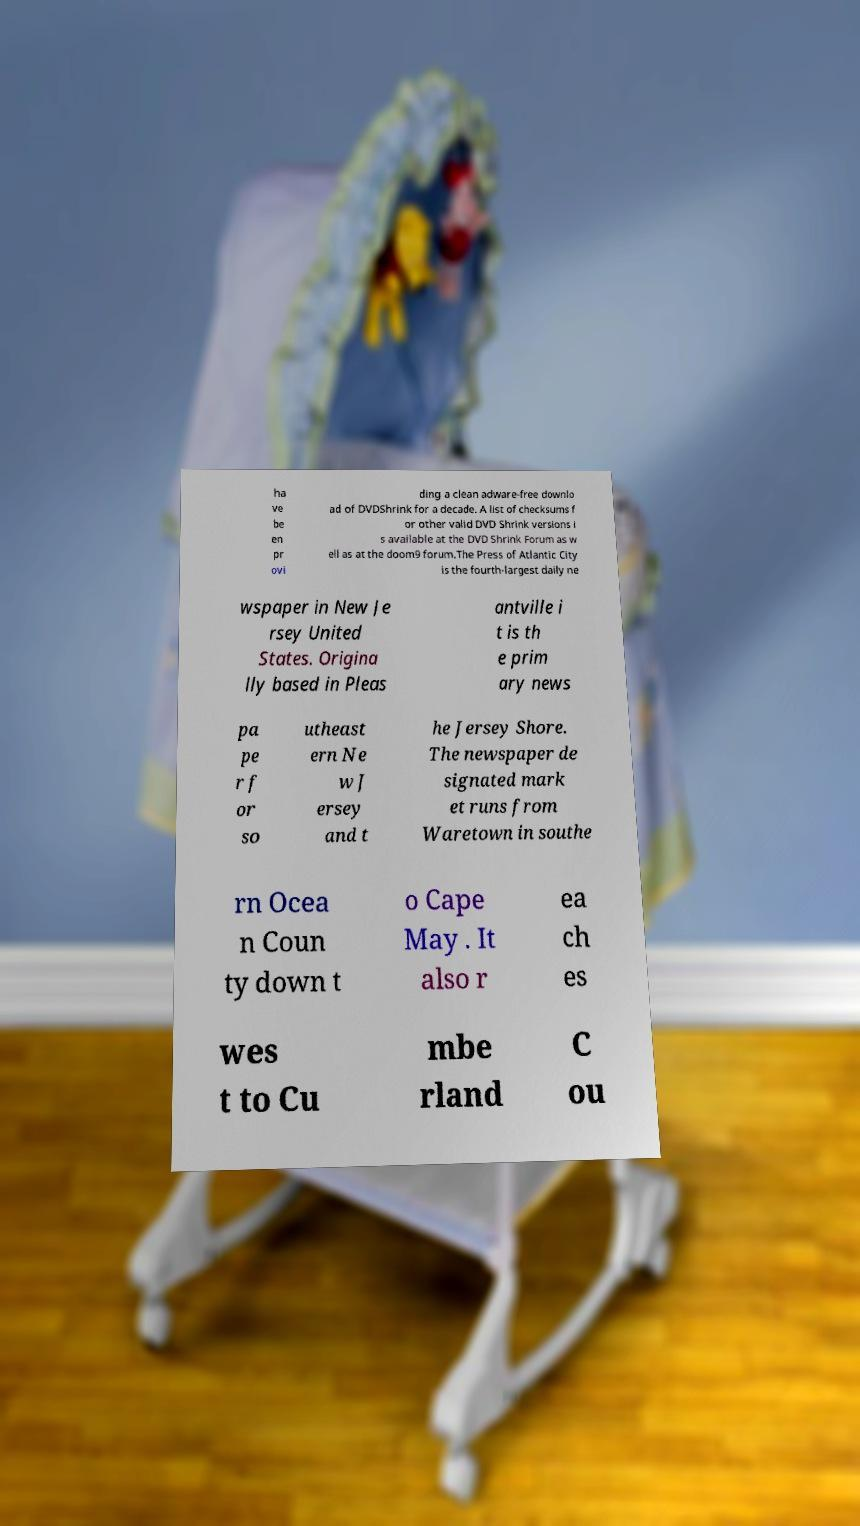Could you assist in decoding the text presented in this image and type it out clearly? ha ve be en pr ovi ding a clean adware-free downlo ad of DVDShrink for a decade. A list of checksums f or other valid DVD Shrink versions i s available at the DVD Shrink Forum as w ell as at the doom9 forum.The Press of Atlantic City is the fourth-largest daily ne wspaper in New Je rsey United States. Origina lly based in Pleas antville i t is th e prim ary news pa pe r f or so utheast ern Ne w J ersey and t he Jersey Shore. The newspaper de signated mark et runs from Waretown in southe rn Ocea n Coun ty down t o Cape May . It also r ea ch es wes t to Cu mbe rland C ou 